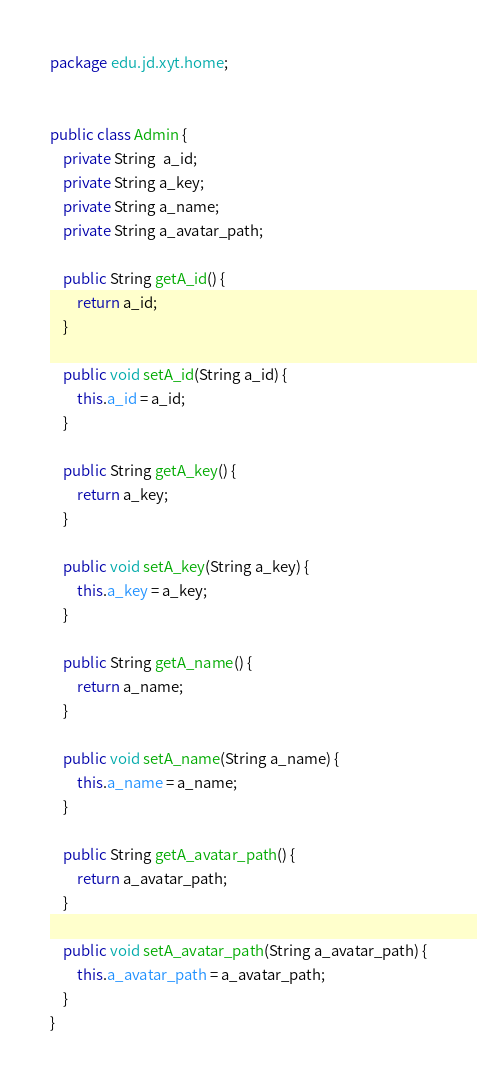Convert code to text. <code><loc_0><loc_0><loc_500><loc_500><_Java_>package edu.jd.xyt.home;


public class Admin {
    private String  a_id;
    private String a_key;
    private String a_name;
    private String a_avatar_path;

    public String getA_id() {
        return a_id;
    }

    public void setA_id(String a_id) {
        this.a_id = a_id;
    }

    public String getA_key() {
        return a_key;
    }

    public void setA_key(String a_key) {
        this.a_key = a_key;
    }

    public String getA_name() {
        return a_name;
    }

    public void setA_name(String a_name) {
        this.a_name = a_name;
    }

    public String getA_avatar_path() {
        return a_avatar_path;
    }

    public void setA_avatar_path(String a_avatar_path) {
        this.a_avatar_path = a_avatar_path;
    }
}
</code> 